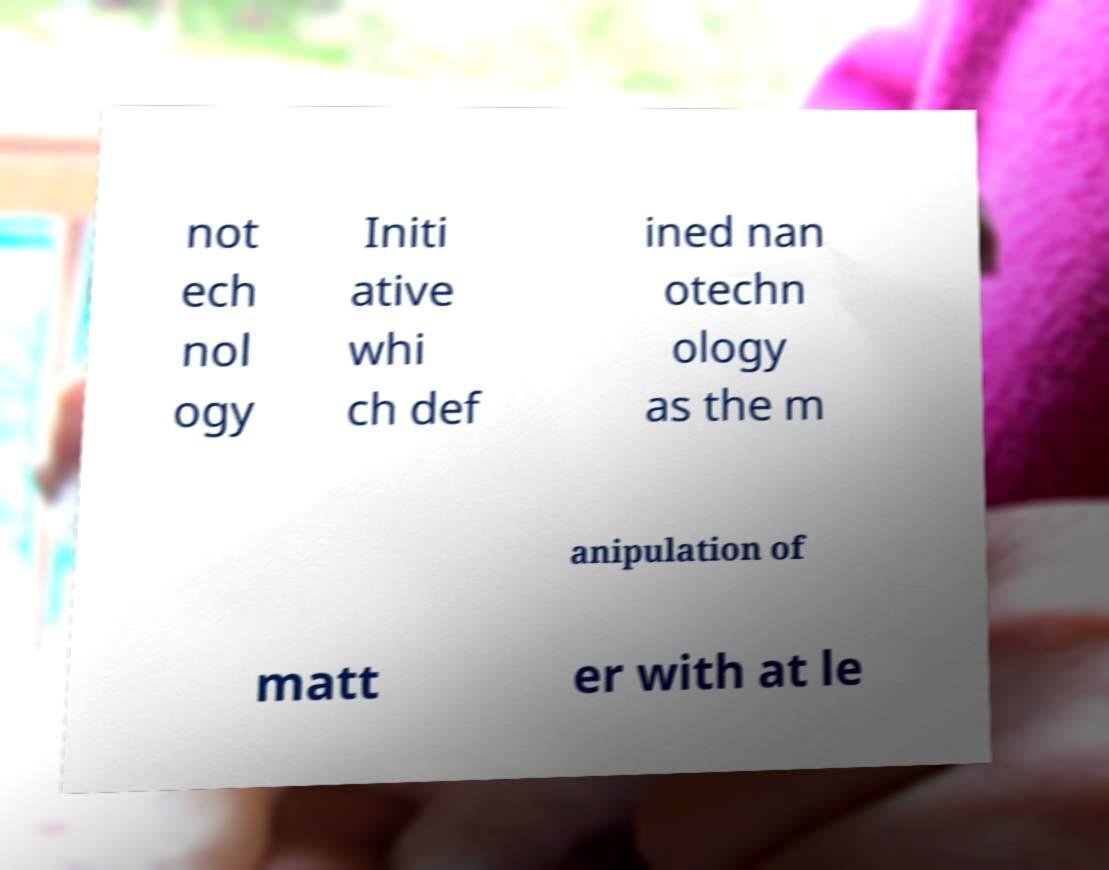Could you assist in decoding the text presented in this image and type it out clearly? not ech nol ogy Initi ative whi ch def ined nan otechn ology as the m anipulation of matt er with at le 